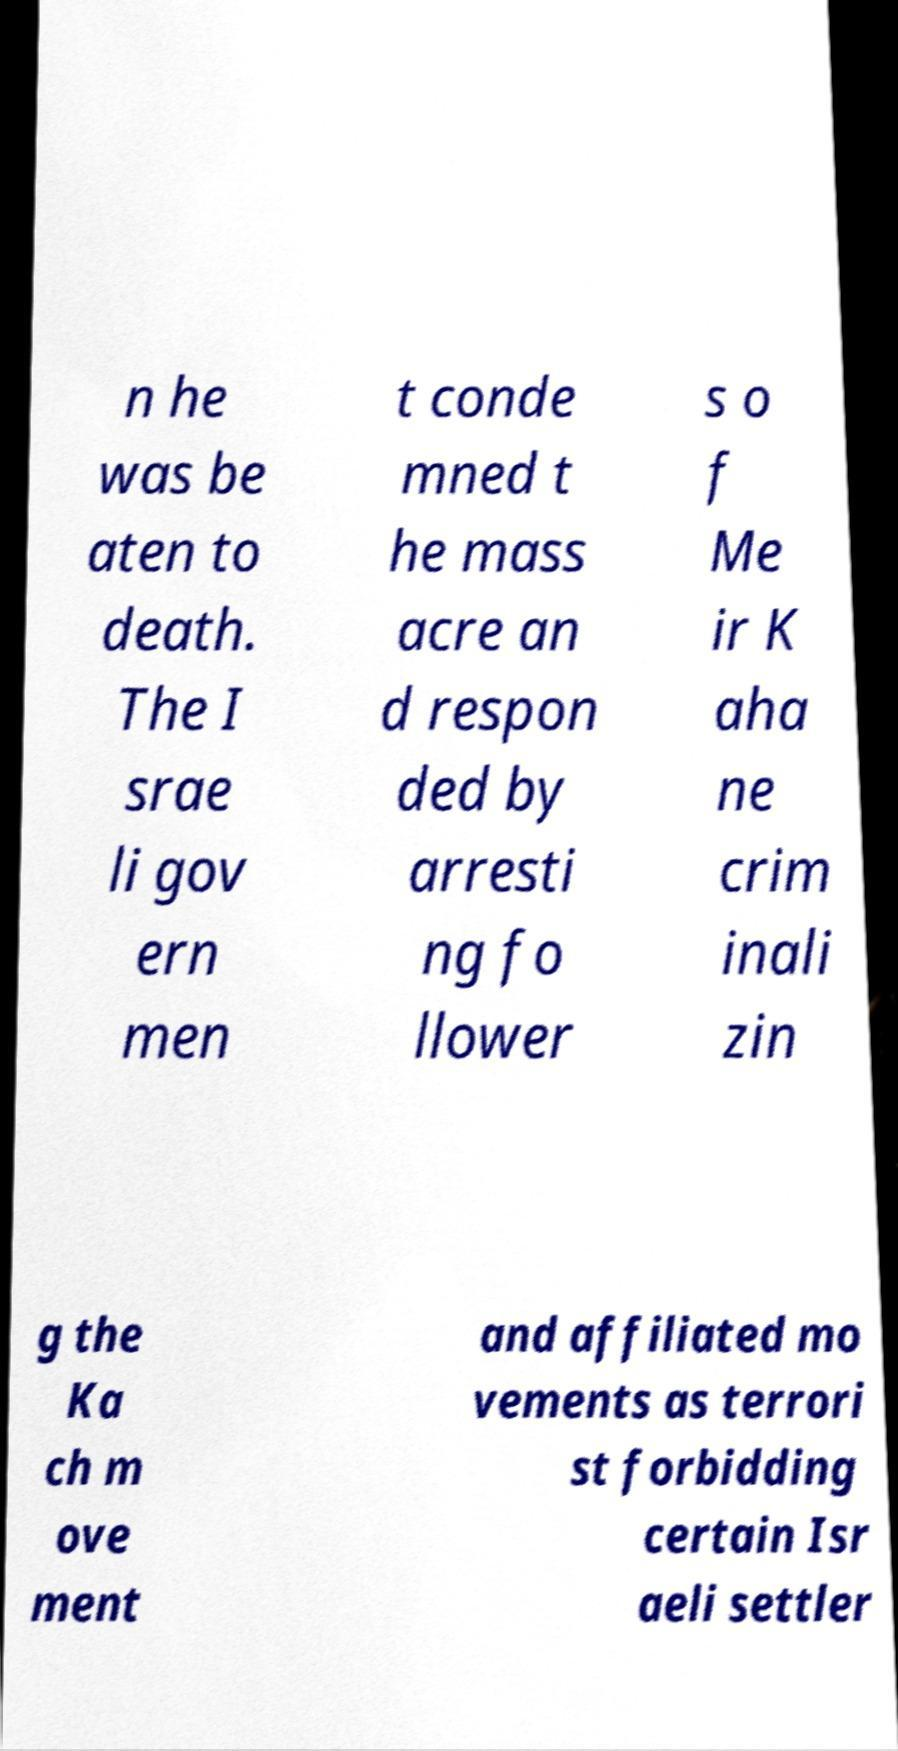I need the written content from this picture converted into text. Can you do that? n he was be aten to death. The I srae li gov ern men t conde mned t he mass acre an d respon ded by arresti ng fo llower s o f Me ir K aha ne crim inali zin g the Ka ch m ove ment and affiliated mo vements as terrori st forbidding certain Isr aeli settler 